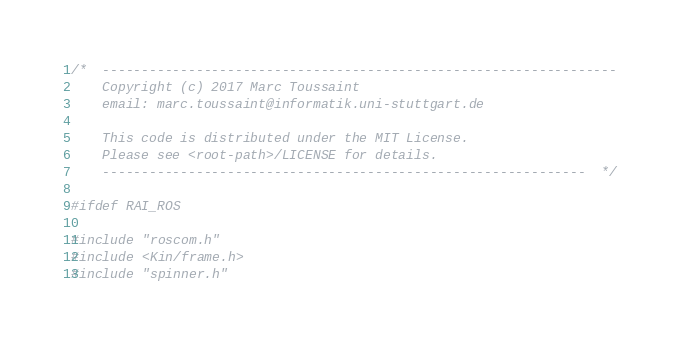<code> <loc_0><loc_0><loc_500><loc_500><_C++_>/*  ------------------------------------------------------------------
    Copyright (c) 2017 Marc Toussaint
    email: marc.toussaint@informatik.uni-stuttgart.de

    This code is distributed under the MIT License.
    Please see <root-path>/LICENSE for details.
    --------------------------------------------------------------  */

#ifdef RAI_ROS

#include "roscom.h"
#include <Kin/frame.h>
#include "spinner.h"
</code> 